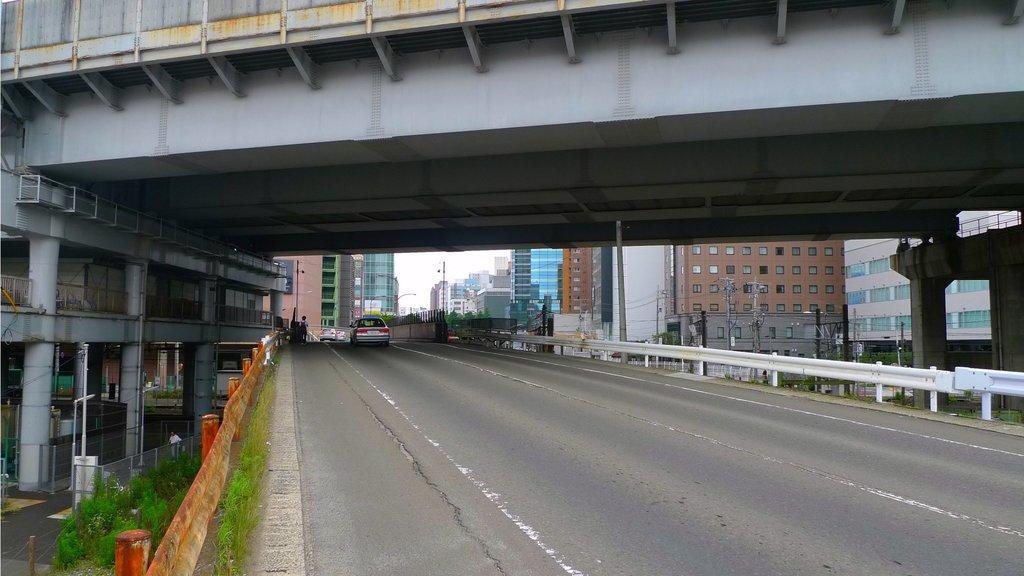Could you give a brief overview of what you see in this image? In the foreground of this picture, there are vehicles moving on the fly over bridge. In the background, there are buildings, and other flyover. On the left side of the image, there is a road, pole, fencing and plants. 